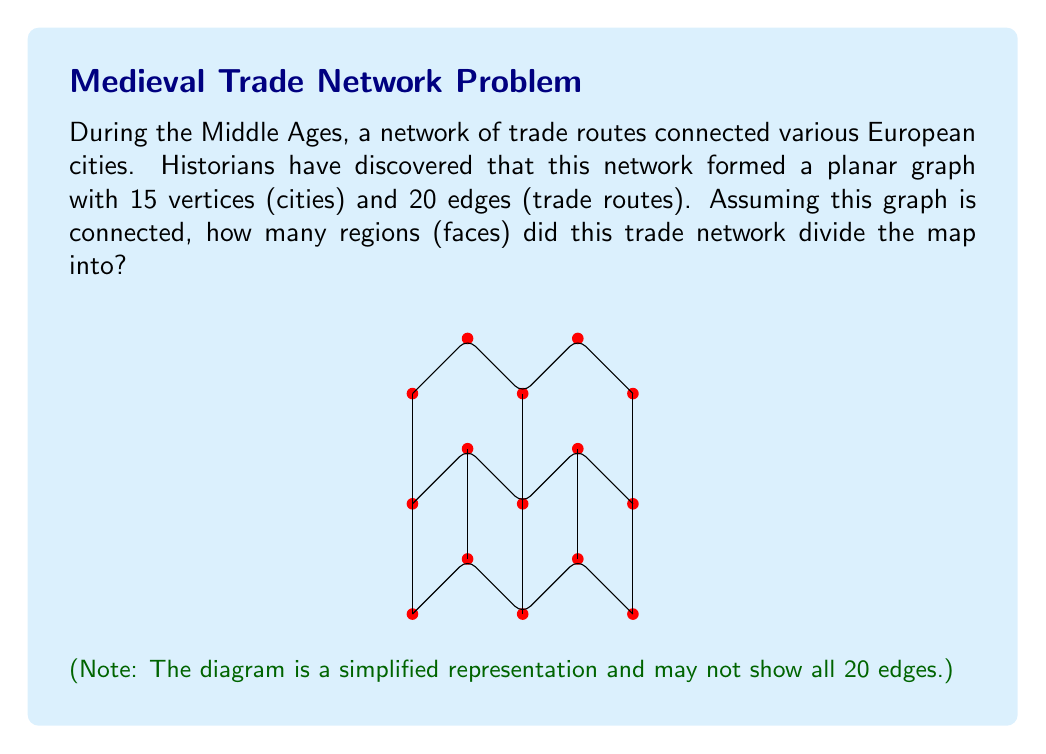Provide a solution to this math problem. To solve this problem, we can use Euler's formula for planar graphs. Let's approach this step-by-step:

1) Euler's formula states that for a connected planar graph:

   $$V - E + F = 2$$

   where $V$ is the number of vertices, $E$ is the number of edges, and $F$ is the number of faces (including the outer face).

2) We are given that:
   - $V = 15$ (15 cities)
   - $E = 20$ (20 trade routes)
   - The graph is connected and planar

3) Let's substitute these values into Euler's formula:

   $$15 - 20 + F = 2$$

4) Now, we can solve for $F$:

   $$F = 2 - 15 + 20 = 7$$

Therefore, the trade network divided the map into 7 regions or faces.

This result aligns with the historical context, as medieval trade routes often created distinct regions or "spheres of influence" across Europe, each with its own economic and cultural characteristics.
Answer: 7 regions 